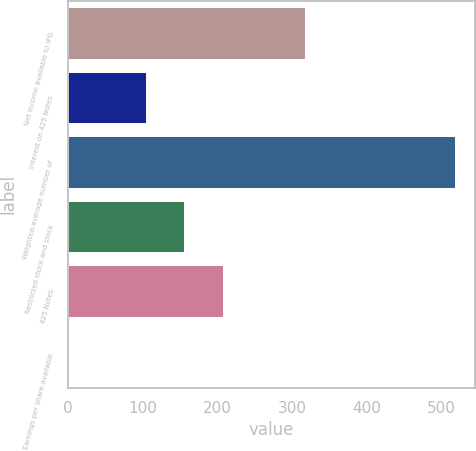Convert chart. <chart><loc_0><loc_0><loc_500><loc_500><bar_chart><fcel>Net income available to IPG<fcel>Interest on 425 Notes<fcel>Weighted-average number of<fcel>Restricted stock and stock<fcel>425 Notes<fcel>Earnings per share available<nl><fcel>316.98<fcel>104.08<fcel>518.3<fcel>155.86<fcel>207.64<fcel>0.52<nl></chart> 